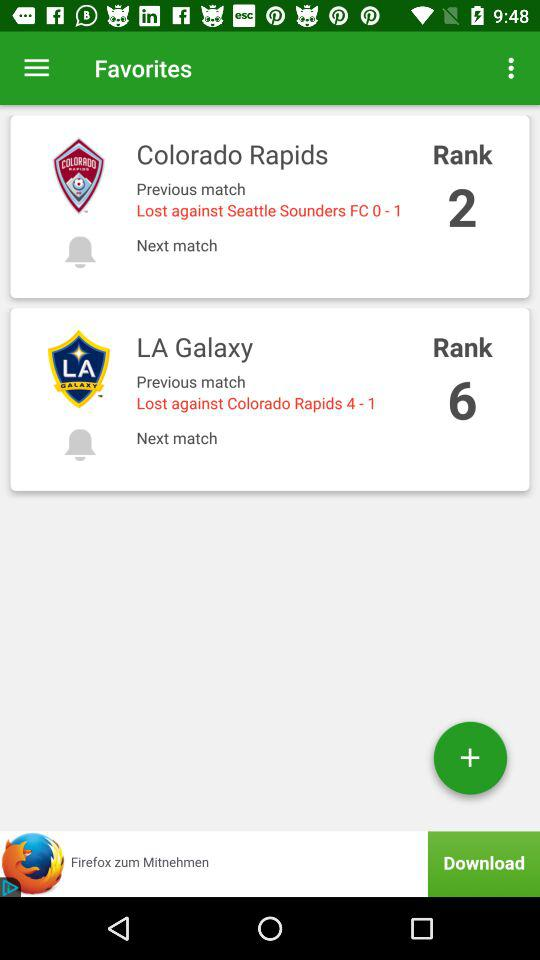What is the rank of the "LA Galaxy"? The rank is 6. 